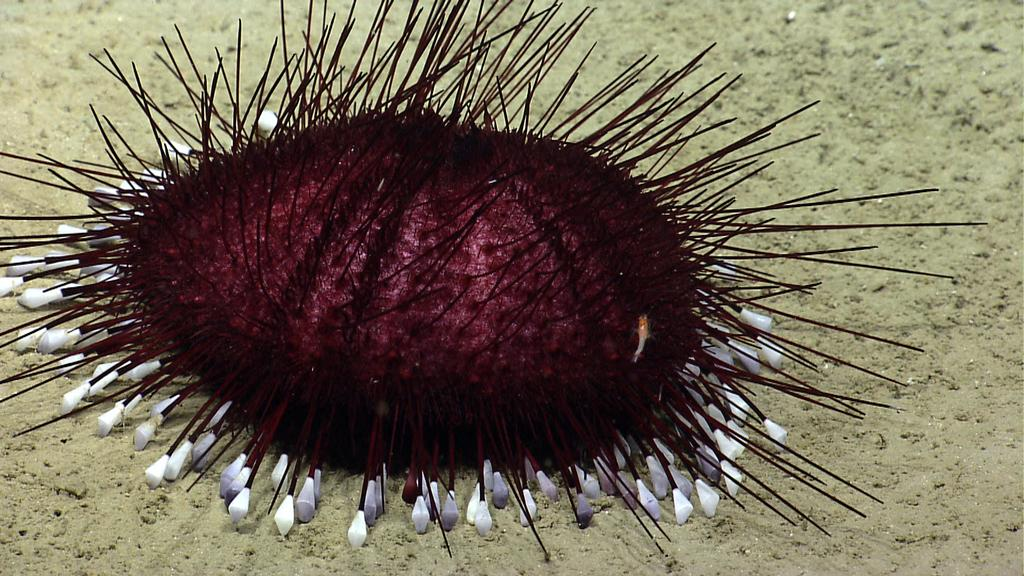What is located on the ground in the image? There is an object on the ground in the image. How does the river flow in the image? There is no river present in the image; it only features an object on the ground. 